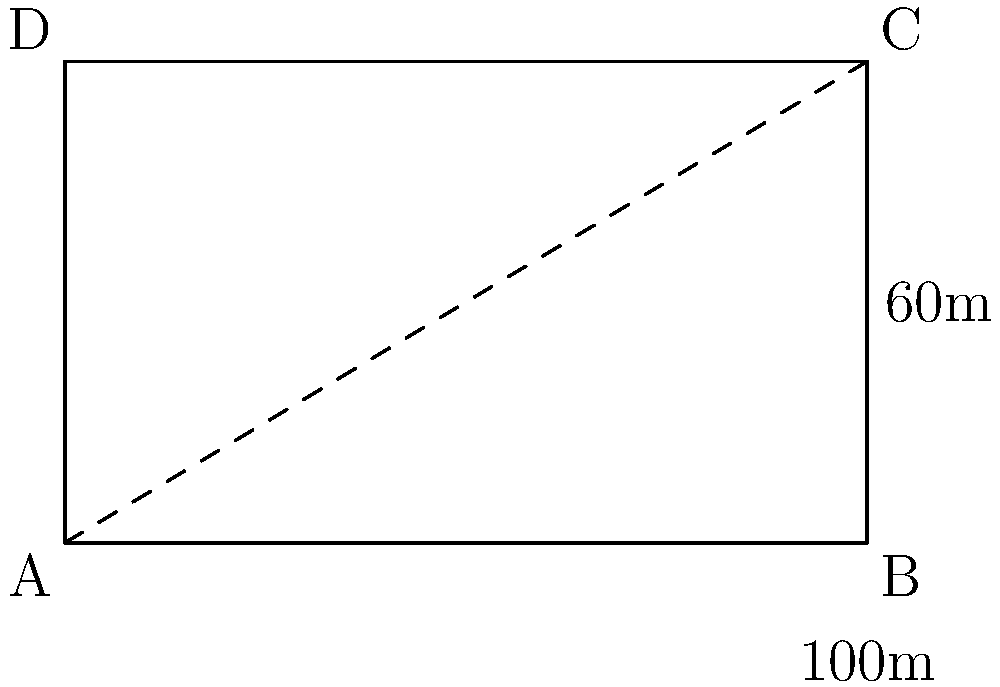The European Parliament building in Brussels has a rectangular base. If the length of the building is 100 meters and the width is 60 meters, what is the length of the diagonal line connecting opposite corners of the building's base? Round your answer to the nearest meter. To find the length of the diagonal, we can use the Pythagorean theorem:

1) Let the diagonal be $x$ meters.

2) The Pythagorean theorem states: $a^2 + b^2 = c^2$, where $c$ is the hypotenuse (diagonal in this case).

3) Substituting our known values:
   $100^2 + 60^2 = x^2$

4) Simplify:
   $10000 + 3600 = x^2$
   $13600 = x^2$

5) Take the square root of both sides:
   $\sqrt{13600} = x$

6) Calculate:
   $x \approx 116.62$ meters

7) Rounding to the nearest meter:
   $x \approx 117$ meters

Therefore, the diagonal of the European Parliament building's base is approximately 117 meters.
Answer: 117 meters 